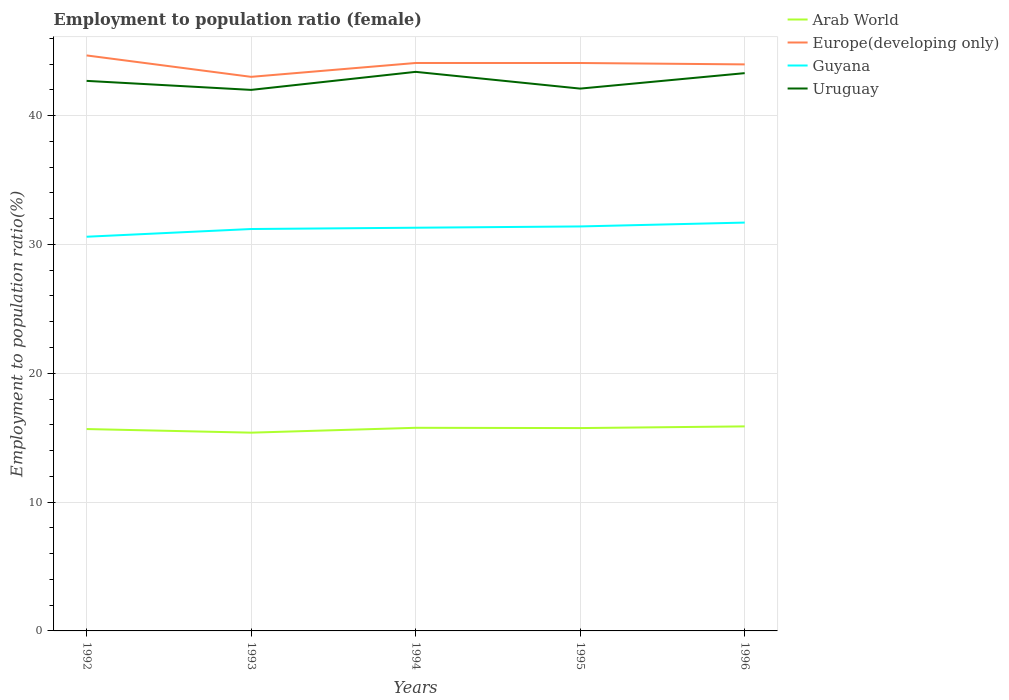Does the line corresponding to Europe(developing only) intersect with the line corresponding to Arab World?
Provide a short and direct response. No. Across all years, what is the maximum employment to population ratio in Arab World?
Your answer should be compact. 15.39. What is the total employment to population ratio in Uruguay in the graph?
Provide a succinct answer. 1.3. What is the difference between the highest and the second highest employment to population ratio in Guyana?
Make the answer very short. 1.1. What is the difference between the highest and the lowest employment to population ratio in Guyana?
Keep it short and to the point. 3. Is the employment to population ratio in Europe(developing only) strictly greater than the employment to population ratio in Arab World over the years?
Offer a very short reply. No. Where does the legend appear in the graph?
Offer a terse response. Top right. How many legend labels are there?
Provide a succinct answer. 4. How are the legend labels stacked?
Offer a very short reply. Vertical. What is the title of the graph?
Offer a very short reply. Employment to population ratio (female). Does "Sint Maarten (Dutch part)" appear as one of the legend labels in the graph?
Keep it short and to the point. No. What is the label or title of the X-axis?
Offer a terse response. Years. What is the label or title of the Y-axis?
Ensure brevity in your answer.  Employment to population ratio(%). What is the Employment to population ratio(%) of Arab World in 1992?
Your response must be concise. 15.67. What is the Employment to population ratio(%) of Europe(developing only) in 1992?
Provide a succinct answer. 44.67. What is the Employment to population ratio(%) of Guyana in 1992?
Make the answer very short. 30.6. What is the Employment to population ratio(%) in Uruguay in 1992?
Keep it short and to the point. 42.7. What is the Employment to population ratio(%) in Arab World in 1993?
Your answer should be compact. 15.39. What is the Employment to population ratio(%) in Europe(developing only) in 1993?
Keep it short and to the point. 43.01. What is the Employment to population ratio(%) in Guyana in 1993?
Your answer should be compact. 31.2. What is the Employment to population ratio(%) of Uruguay in 1993?
Ensure brevity in your answer.  42. What is the Employment to population ratio(%) of Arab World in 1994?
Keep it short and to the point. 15.77. What is the Employment to population ratio(%) of Europe(developing only) in 1994?
Keep it short and to the point. 44.09. What is the Employment to population ratio(%) of Guyana in 1994?
Ensure brevity in your answer.  31.3. What is the Employment to population ratio(%) in Uruguay in 1994?
Make the answer very short. 43.4. What is the Employment to population ratio(%) in Arab World in 1995?
Offer a very short reply. 15.75. What is the Employment to population ratio(%) of Europe(developing only) in 1995?
Your response must be concise. 44.09. What is the Employment to population ratio(%) of Guyana in 1995?
Keep it short and to the point. 31.4. What is the Employment to population ratio(%) in Uruguay in 1995?
Provide a short and direct response. 42.1. What is the Employment to population ratio(%) in Arab World in 1996?
Give a very brief answer. 15.88. What is the Employment to population ratio(%) in Europe(developing only) in 1996?
Offer a very short reply. 43.98. What is the Employment to population ratio(%) in Guyana in 1996?
Your answer should be very brief. 31.7. What is the Employment to population ratio(%) in Uruguay in 1996?
Provide a succinct answer. 43.3. Across all years, what is the maximum Employment to population ratio(%) of Arab World?
Give a very brief answer. 15.88. Across all years, what is the maximum Employment to population ratio(%) in Europe(developing only)?
Provide a succinct answer. 44.67. Across all years, what is the maximum Employment to population ratio(%) of Guyana?
Give a very brief answer. 31.7. Across all years, what is the maximum Employment to population ratio(%) of Uruguay?
Keep it short and to the point. 43.4. Across all years, what is the minimum Employment to population ratio(%) in Arab World?
Give a very brief answer. 15.39. Across all years, what is the minimum Employment to population ratio(%) of Europe(developing only)?
Give a very brief answer. 43.01. Across all years, what is the minimum Employment to population ratio(%) of Guyana?
Ensure brevity in your answer.  30.6. Across all years, what is the minimum Employment to population ratio(%) of Uruguay?
Ensure brevity in your answer.  42. What is the total Employment to population ratio(%) in Arab World in the graph?
Offer a terse response. 78.46. What is the total Employment to population ratio(%) in Europe(developing only) in the graph?
Your answer should be very brief. 219.84. What is the total Employment to population ratio(%) in Guyana in the graph?
Your response must be concise. 156.2. What is the total Employment to population ratio(%) in Uruguay in the graph?
Provide a short and direct response. 213.5. What is the difference between the Employment to population ratio(%) in Arab World in 1992 and that in 1993?
Make the answer very short. 0.28. What is the difference between the Employment to population ratio(%) in Europe(developing only) in 1992 and that in 1993?
Make the answer very short. 1.66. What is the difference between the Employment to population ratio(%) of Uruguay in 1992 and that in 1993?
Make the answer very short. 0.7. What is the difference between the Employment to population ratio(%) in Arab World in 1992 and that in 1994?
Give a very brief answer. -0.1. What is the difference between the Employment to population ratio(%) in Europe(developing only) in 1992 and that in 1994?
Offer a very short reply. 0.59. What is the difference between the Employment to population ratio(%) in Guyana in 1992 and that in 1994?
Give a very brief answer. -0.7. What is the difference between the Employment to population ratio(%) in Uruguay in 1992 and that in 1994?
Offer a terse response. -0.7. What is the difference between the Employment to population ratio(%) in Arab World in 1992 and that in 1995?
Ensure brevity in your answer.  -0.07. What is the difference between the Employment to population ratio(%) of Europe(developing only) in 1992 and that in 1995?
Offer a terse response. 0.59. What is the difference between the Employment to population ratio(%) in Guyana in 1992 and that in 1995?
Provide a short and direct response. -0.8. What is the difference between the Employment to population ratio(%) in Uruguay in 1992 and that in 1995?
Your answer should be very brief. 0.6. What is the difference between the Employment to population ratio(%) in Arab World in 1992 and that in 1996?
Your answer should be very brief. -0.21. What is the difference between the Employment to population ratio(%) of Europe(developing only) in 1992 and that in 1996?
Keep it short and to the point. 0.7. What is the difference between the Employment to population ratio(%) of Guyana in 1992 and that in 1996?
Ensure brevity in your answer.  -1.1. What is the difference between the Employment to population ratio(%) of Arab World in 1993 and that in 1994?
Ensure brevity in your answer.  -0.38. What is the difference between the Employment to population ratio(%) of Europe(developing only) in 1993 and that in 1994?
Your answer should be very brief. -1.08. What is the difference between the Employment to population ratio(%) in Guyana in 1993 and that in 1994?
Make the answer very short. -0.1. What is the difference between the Employment to population ratio(%) of Arab World in 1993 and that in 1995?
Keep it short and to the point. -0.35. What is the difference between the Employment to population ratio(%) of Europe(developing only) in 1993 and that in 1995?
Keep it short and to the point. -1.07. What is the difference between the Employment to population ratio(%) in Guyana in 1993 and that in 1995?
Your answer should be very brief. -0.2. What is the difference between the Employment to population ratio(%) in Arab World in 1993 and that in 1996?
Give a very brief answer. -0.49. What is the difference between the Employment to population ratio(%) in Europe(developing only) in 1993 and that in 1996?
Give a very brief answer. -0.97. What is the difference between the Employment to population ratio(%) in Uruguay in 1993 and that in 1996?
Keep it short and to the point. -1.3. What is the difference between the Employment to population ratio(%) in Arab World in 1994 and that in 1995?
Ensure brevity in your answer.  0.02. What is the difference between the Employment to population ratio(%) of Europe(developing only) in 1994 and that in 1995?
Provide a succinct answer. 0. What is the difference between the Employment to population ratio(%) in Guyana in 1994 and that in 1995?
Make the answer very short. -0.1. What is the difference between the Employment to population ratio(%) of Uruguay in 1994 and that in 1995?
Provide a succinct answer. 1.3. What is the difference between the Employment to population ratio(%) in Arab World in 1994 and that in 1996?
Keep it short and to the point. -0.11. What is the difference between the Employment to population ratio(%) of Europe(developing only) in 1994 and that in 1996?
Your answer should be compact. 0.11. What is the difference between the Employment to population ratio(%) in Arab World in 1995 and that in 1996?
Give a very brief answer. -0.13. What is the difference between the Employment to population ratio(%) of Europe(developing only) in 1995 and that in 1996?
Your answer should be compact. 0.11. What is the difference between the Employment to population ratio(%) of Guyana in 1995 and that in 1996?
Provide a succinct answer. -0.3. What is the difference between the Employment to population ratio(%) in Arab World in 1992 and the Employment to population ratio(%) in Europe(developing only) in 1993?
Offer a very short reply. -27.34. What is the difference between the Employment to population ratio(%) of Arab World in 1992 and the Employment to population ratio(%) of Guyana in 1993?
Give a very brief answer. -15.53. What is the difference between the Employment to population ratio(%) of Arab World in 1992 and the Employment to population ratio(%) of Uruguay in 1993?
Keep it short and to the point. -26.33. What is the difference between the Employment to population ratio(%) of Europe(developing only) in 1992 and the Employment to population ratio(%) of Guyana in 1993?
Keep it short and to the point. 13.47. What is the difference between the Employment to population ratio(%) of Europe(developing only) in 1992 and the Employment to population ratio(%) of Uruguay in 1993?
Offer a terse response. 2.67. What is the difference between the Employment to population ratio(%) in Arab World in 1992 and the Employment to population ratio(%) in Europe(developing only) in 1994?
Provide a short and direct response. -28.42. What is the difference between the Employment to population ratio(%) in Arab World in 1992 and the Employment to population ratio(%) in Guyana in 1994?
Provide a succinct answer. -15.63. What is the difference between the Employment to population ratio(%) of Arab World in 1992 and the Employment to population ratio(%) of Uruguay in 1994?
Make the answer very short. -27.73. What is the difference between the Employment to population ratio(%) in Europe(developing only) in 1992 and the Employment to population ratio(%) in Guyana in 1994?
Provide a short and direct response. 13.37. What is the difference between the Employment to population ratio(%) of Europe(developing only) in 1992 and the Employment to population ratio(%) of Uruguay in 1994?
Ensure brevity in your answer.  1.27. What is the difference between the Employment to population ratio(%) in Arab World in 1992 and the Employment to population ratio(%) in Europe(developing only) in 1995?
Give a very brief answer. -28.42. What is the difference between the Employment to population ratio(%) of Arab World in 1992 and the Employment to population ratio(%) of Guyana in 1995?
Your response must be concise. -15.73. What is the difference between the Employment to population ratio(%) in Arab World in 1992 and the Employment to population ratio(%) in Uruguay in 1995?
Your response must be concise. -26.43. What is the difference between the Employment to population ratio(%) of Europe(developing only) in 1992 and the Employment to population ratio(%) of Guyana in 1995?
Ensure brevity in your answer.  13.27. What is the difference between the Employment to population ratio(%) of Europe(developing only) in 1992 and the Employment to population ratio(%) of Uruguay in 1995?
Ensure brevity in your answer.  2.57. What is the difference between the Employment to population ratio(%) in Guyana in 1992 and the Employment to population ratio(%) in Uruguay in 1995?
Provide a short and direct response. -11.5. What is the difference between the Employment to population ratio(%) in Arab World in 1992 and the Employment to population ratio(%) in Europe(developing only) in 1996?
Make the answer very short. -28.31. What is the difference between the Employment to population ratio(%) in Arab World in 1992 and the Employment to population ratio(%) in Guyana in 1996?
Ensure brevity in your answer.  -16.03. What is the difference between the Employment to population ratio(%) of Arab World in 1992 and the Employment to population ratio(%) of Uruguay in 1996?
Provide a short and direct response. -27.63. What is the difference between the Employment to population ratio(%) in Europe(developing only) in 1992 and the Employment to population ratio(%) in Guyana in 1996?
Your answer should be compact. 12.97. What is the difference between the Employment to population ratio(%) in Europe(developing only) in 1992 and the Employment to population ratio(%) in Uruguay in 1996?
Provide a succinct answer. 1.37. What is the difference between the Employment to population ratio(%) in Guyana in 1992 and the Employment to population ratio(%) in Uruguay in 1996?
Your answer should be very brief. -12.7. What is the difference between the Employment to population ratio(%) in Arab World in 1993 and the Employment to population ratio(%) in Europe(developing only) in 1994?
Your response must be concise. -28.7. What is the difference between the Employment to population ratio(%) of Arab World in 1993 and the Employment to population ratio(%) of Guyana in 1994?
Your response must be concise. -15.91. What is the difference between the Employment to population ratio(%) of Arab World in 1993 and the Employment to population ratio(%) of Uruguay in 1994?
Your response must be concise. -28.01. What is the difference between the Employment to population ratio(%) in Europe(developing only) in 1993 and the Employment to population ratio(%) in Guyana in 1994?
Offer a terse response. 11.71. What is the difference between the Employment to population ratio(%) of Europe(developing only) in 1993 and the Employment to population ratio(%) of Uruguay in 1994?
Ensure brevity in your answer.  -0.39. What is the difference between the Employment to population ratio(%) of Arab World in 1993 and the Employment to population ratio(%) of Europe(developing only) in 1995?
Give a very brief answer. -28.7. What is the difference between the Employment to population ratio(%) in Arab World in 1993 and the Employment to population ratio(%) in Guyana in 1995?
Your answer should be very brief. -16.01. What is the difference between the Employment to population ratio(%) in Arab World in 1993 and the Employment to population ratio(%) in Uruguay in 1995?
Keep it short and to the point. -26.71. What is the difference between the Employment to population ratio(%) of Europe(developing only) in 1993 and the Employment to population ratio(%) of Guyana in 1995?
Your answer should be very brief. 11.61. What is the difference between the Employment to population ratio(%) in Europe(developing only) in 1993 and the Employment to population ratio(%) in Uruguay in 1995?
Your answer should be very brief. 0.91. What is the difference between the Employment to population ratio(%) in Arab World in 1993 and the Employment to population ratio(%) in Europe(developing only) in 1996?
Provide a short and direct response. -28.59. What is the difference between the Employment to population ratio(%) of Arab World in 1993 and the Employment to population ratio(%) of Guyana in 1996?
Offer a very short reply. -16.31. What is the difference between the Employment to population ratio(%) in Arab World in 1993 and the Employment to population ratio(%) in Uruguay in 1996?
Offer a very short reply. -27.91. What is the difference between the Employment to population ratio(%) in Europe(developing only) in 1993 and the Employment to population ratio(%) in Guyana in 1996?
Provide a succinct answer. 11.31. What is the difference between the Employment to population ratio(%) of Europe(developing only) in 1993 and the Employment to population ratio(%) of Uruguay in 1996?
Ensure brevity in your answer.  -0.29. What is the difference between the Employment to population ratio(%) in Guyana in 1993 and the Employment to population ratio(%) in Uruguay in 1996?
Ensure brevity in your answer.  -12.1. What is the difference between the Employment to population ratio(%) of Arab World in 1994 and the Employment to population ratio(%) of Europe(developing only) in 1995?
Give a very brief answer. -28.32. What is the difference between the Employment to population ratio(%) of Arab World in 1994 and the Employment to population ratio(%) of Guyana in 1995?
Offer a very short reply. -15.63. What is the difference between the Employment to population ratio(%) of Arab World in 1994 and the Employment to population ratio(%) of Uruguay in 1995?
Your answer should be very brief. -26.33. What is the difference between the Employment to population ratio(%) in Europe(developing only) in 1994 and the Employment to population ratio(%) in Guyana in 1995?
Ensure brevity in your answer.  12.69. What is the difference between the Employment to population ratio(%) of Europe(developing only) in 1994 and the Employment to population ratio(%) of Uruguay in 1995?
Your answer should be compact. 1.99. What is the difference between the Employment to population ratio(%) of Guyana in 1994 and the Employment to population ratio(%) of Uruguay in 1995?
Provide a succinct answer. -10.8. What is the difference between the Employment to population ratio(%) of Arab World in 1994 and the Employment to population ratio(%) of Europe(developing only) in 1996?
Your response must be concise. -28.21. What is the difference between the Employment to population ratio(%) in Arab World in 1994 and the Employment to population ratio(%) in Guyana in 1996?
Give a very brief answer. -15.93. What is the difference between the Employment to population ratio(%) in Arab World in 1994 and the Employment to population ratio(%) in Uruguay in 1996?
Ensure brevity in your answer.  -27.53. What is the difference between the Employment to population ratio(%) of Europe(developing only) in 1994 and the Employment to population ratio(%) of Guyana in 1996?
Your answer should be compact. 12.39. What is the difference between the Employment to population ratio(%) of Europe(developing only) in 1994 and the Employment to population ratio(%) of Uruguay in 1996?
Offer a very short reply. 0.79. What is the difference between the Employment to population ratio(%) in Guyana in 1994 and the Employment to population ratio(%) in Uruguay in 1996?
Ensure brevity in your answer.  -12. What is the difference between the Employment to population ratio(%) in Arab World in 1995 and the Employment to population ratio(%) in Europe(developing only) in 1996?
Keep it short and to the point. -28.23. What is the difference between the Employment to population ratio(%) of Arab World in 1995 and the Employment to population ratio(%) of Guyana in 1996?
Offer a very short reply. -15.95. What is the difference between the Employment to population ratio(%) in Arab World in 1995 and the Employment to population ratio(%) in Uruguay in 1996?
Provide a succinct answer. -27.55. What is the difference between the Employment to population ratio(%) of Europe(developing only) in 1995 and the Employment to population ratio(%) of Guyana in 1996?
Provide a succinct answer. 12.39. What is the difference between the Employment to population ratio(%) of Europe(developing only) in 1995 and the Employment to population ratio(%) of Uruguay in 1996?
Your answer should be compact. 0.79. What is the difference between the Employment to population ratio(%) of Guyana in 1995 and the Employment to population ratio(%) of Uruguay in 1996?
Your answer should be compact. -11.9. What is the average Employment to population ratio(%) in Arab World per year?
Your response must be concise. 15.69. What is the average Employment to population ratio(%) of Europe(developing only) per year?
Offer a very short reply. 43.97. What is the average Employment to population ratio(%) in Guyana per year?
Keep it short and to the point. 31.24. What is the average Employment to population ratio(%) in Uruguay per year?
Give a very brief answer. 42.7. In the year 1992, what is the difference between the Employment to population ratio(%) in Arab World and Employment to population ratio(%) in Europe(developing only)?
Provide a short and direct response. -29. In the year 1992, what is the difference between the Employment to population ratio(%) of Arab World and Employment to population ratio(%) of Guyana?
Your answer should be very brief. -14.93. In the year 1992, what is the difference between the Employment to population ratio(%) in Arab World and Employment to population ratio(%) in Uruguay?
Offer a very short reply. -27.03. In the year 1992, what is the difference between the Employment to population ratio(%) of Europe(developing only) and Employment to population ratio(%) of Guyana?
Offer a very short reply. 14.07. In the year 1992, what is the difference between the Employment to population ratio(%) in Europe(developing only) and Employment to population ratio(%) in Uruguay?
Give a very brief answer. 1.97. In the year 1992, what is the difference between the Employment to population ratio(%) of Guyana and Employment to population ratio(%) of Uruguay?
Offer a terse response. -12.1. In the year 1993, what is the difference between the Employment to population ratio(%) in Arab World and Employment to population ratio(%) in Europe(developing only)?
Your answer should be compact. -27.62. In the year 1993, what is the difference between the Employment to population ratio(%) of Arab World and Employment to population ratio(%) of Guyana?
Your response must be concise. -15.81. In the year 1993, what is the difference between the Employment to population ratio(%) of Arab World and Employment to population ratio(%) of Uruguay?
Provide a succinct answer. -26.61. In the year 1993, what is the difference between the Employment to population ratio(%) of Europe(developing only) and Employment to population ratio(%) of Guyana?
Provide a short and direct response. 11.81. In the year 1993, what is the difference between the Employment to population ratio(%) of Europe(developing only) and Employment to population ratio(%) of Uruguay?
Ensure brevity in your answer.  1.01. In the year 1993, what is the difference between the Employment to population ratio(%) of Guyana and Employment to population ratio(%) of Uruguay?
Provide a succinct answer. -10.8. In the year 1994, what is the difference between the Employment to population ratio(%) in Arab World and Employment to population ratio(%) in Europe(developing only)?
Your answer should be compact. -28.32. In the year 1994, what is the difference between the Employment to population ratio(%) in Arab World and Employment to population ratio(%) in Guyana?
Ensure brevity in your answer.  -15.53. In the year 1994, what is the difference between the Employment to population ratio(%) in Arab World and Employment to population ratio(%) in Uruguay?
Ensure brevity in your answer.  -27.63. In the year 1994, what is the difference between the Employment to population ratio(%) of Europe(developing only) and Employment to population ratio(%) of Guyana?
Make the answer very short. 12.79. In the year 1994, what is the difference between the Employment to population ratio(%) in Europe(developing only) and Employment to population ratio(%) in Uruguay?
Your response must be concise. 0.69. In the year 1994, what is the difference between the Employment to population ratio(%) in Guyana and Employment to population ratio(%) in Uruguay?
Offer a terse response. -12.1. In the year 1995, what is the difference between the Employment to population ratio(%) of Arab World and Employment to population ratio(%) of Europe(developing only)?
Make the answer very short. -28.34. In the year 1995, what is the difference between the Employment to population ratio(%) of Arab World and Employment to population ratio(%) of Guyana?
Provide a succinct answer. -15.65. In the year 1995, what is the difference between the Employment to population ratio(%) of Arab World and Employment to population ratio(%) of Uruguay?
Give a very brief answer. -26.35. In the year 1995, what is the difference between the Employment to population ratio(%) in Europe(developing only) and Employment to population ratio(%) in Guyana?
Offer a terse response. 12.69. In the year 1995, what is the difference between the Employment to population ratio(%) in Europe(developing only) and Employment to population ratio(%) in Uruguay?
Make the answer very short. 1.99. In the year 1995, what is the difference between the Employment to population ratio(%) in Guyana and Employment to population ratio(%) in Uruguay?
Provide a succinct answer. -10.7. In the year 1996, what is the difference between the Employment to population ratio(%) in Arab World and Employment to population ratio(%) in Europe(developing only)?
Your answer should be compact. -28.1. In the year 1996, what is the difference between the Employment to population ratio(%) of Arab World and Employment to population ratio(%) of Guyana?
Give a very brief answer. -15.82. In the year 1996, what is the difference between the Employment to population ratio(%) in Arab World and Employment to population ratio(%) in Uruguay?
Make the answer very short. -27.42. In the year 1996, what is the difference between the Employment to population ratio(%) in Europe(developing only) and Employment to population ratio(%) in Guyana?
Offer a very short reply. 12.28. In the year 1996, what is the difference between the Employment to population ratio(%) of Europe(developing only) and Employment to population ratio(%) of Uruguay?
Offer a terse response. 0.68. In the year 1996, what is the difference between the Employment to population ratio(%) of Guyana and Employment to population ratio(%) of Uruguay?
Give a very brief answer. -11.6. What is the ratio of the Employment to population ratio(%) in Arab World in 1992 to that in 1993?
Your response must be concise. 1.02. What is the ratio of the Employment to population ratio(%) in Europe(developing only) in 1992 to that in 1993?
Keep it short and to the point. 1.04. What is the ratio of the Employment to population ratio(%) in Guyana in 1992 to that in 1993?
Your answer should be compact. 0.98. What is the ratio of the Employment to population ratio(%) of Uruguay in 1992 to that in 1993?
Keep it short and to the point. 1.02. What is the ratio of the Employment to population ratio(%) of Arab World in 1992 to that in 1994?
Offer a terse response. 0.99. What is the ratio of the Employment to population ratio(%) in Europe(developing only) in 1992 to that in 1994?
Provide a succinct answer. 1.01. What is the ratio of the Employment to population ratio(%) of Guyana in 1992 to that in 1994?
Offer a very short reply. 0.98. What is the ratio of the Employment to population ratio(%) in Uruguay in 1992 to that in 1994?
Your answer should be very brief. 0.98. What is the ratio of the Employment to population ratio(%) in Europe(developing only) in 1992 to that in 1995?
Provide a short and direct response. 1.01. What is the ratio of the Employment to population ratio(%) in Guyana in 1992 to that in 1995?
Offer a terse response. 0.97. What is the ratio of the Employment to population ratio(%) of Uruguay in 1992 to that in 1995?
Your answer should be very brief. 1.01. What is the ratio of the Employment to population ratio(%) of Arab World in 1992 to that in 1996?
Offer a terse response. 0.99. What is the ratio of the Employment to population ratio(%) of Europe(developing only) in 1992 to that in 1996?
Provide a short and direct response. 1.02. What is the ratio of the Employment to population ratio(%) in Guyana in 1992 to that in 1996?
Offer a very short reply. 0.97. What is the ratio of the Employment to population ratio(%) of Uruguay in 1992 to that in 1996?
Ensure brevity in your answer.  0.99. What is the ratio of the Employment to population ratio(%) in Arab World in 1993 to that in 1994?
Offer a terse response. 0.98. What is the ratio of the Employment to population ratio(%) in Europe(developing only) in 1993 to that in 1994?
Offer a terse response. 0.98. What is the ratio of the Employment to population ratio(%) in Guyana in 1993 to that in 1994?
Make the answer very short. 1. What is the ratio of the Employment to population ratio(%) in Uruguay in 1993 to that in 1994?
Make the answer very short. 0.97. What is the ratio of the Employment to population ratio(%) of Arab World in 1993 to that in 1995?
Provide a succinct answer. 0.98. What is the ratio of the Employment to population ratio(%) of Europe(developing only) in 1993 to that in 1995?
Your response must be concise. 0.98. What is the ratio of the Employment to population ratio(%) of Uruguay in 1993 to that in 1995?
Your response must be concise. 1. What is the ratio of the Employment to population ratio(%) of Arab World in 1993 to that in 1996?
Keep it short and to the point. 0.97. What is the ratio of the Employment to population ratio(%) in Europe(developing only) in 1993 to that in 1996?
Your answer should be compact. 0.98. What is the ratio of the Employment to population ratio(%) of Guyana in 1993 to that in 1996?
Offer a very short reply. 0.98. What is the ratio of the Employment to population ratio(%) of Arab World in 1994 to that in 1995?
Make the answer very short. 1. What is the ratio of the Employment to population ratio(%) of Europe(developing only) in 1994 to that in 1995?
Give a very brief answer. 1. What is the ratio of the Employment to population ratio(%) in Guyana in 1994 to that in 1995?
Offer a very short reply. 1. What is the ratio of the Employment to population ratio(%) in Uruguay in 1994 to that in 1995?
Give a very brief answer. 1.03. What is the ratio of the Employment to population ratio(%) of Arab World in 1994 to that in 1996?
Give a very brief answer. 0.99. What is the ratio of the Employment to population ratio(%) in Guyana in 1994 to that in 1996?
Make the answer very short. 0.99. What is the ratio of the Employment to population ratio(%) of Uruguay in 1995 to that in 1996?
Offer a terse response. 0.97. What is the difference between the highest and the second highest Employment to population ratio(%) of Arab World?
Provide a short and direct response. 0.11. What is the difference between the highest and the second highest Employment to population ratio(%) of Europe(developing only)?
Keep it short and to the point. 0.59. What is the difference between the highest and the second highest Employment to population ratio(%) in Guyana?
Provide a succinct answer. 0.3. What is the difference between the highest and the lowest Employment to population ratio(%) in Arab World?
Your response must be concise. 0.49. What is the difference between the highest and the lowest Employment to population ratio(%) of Europe(developing only)?
Give a very brief answer. 1.66. 